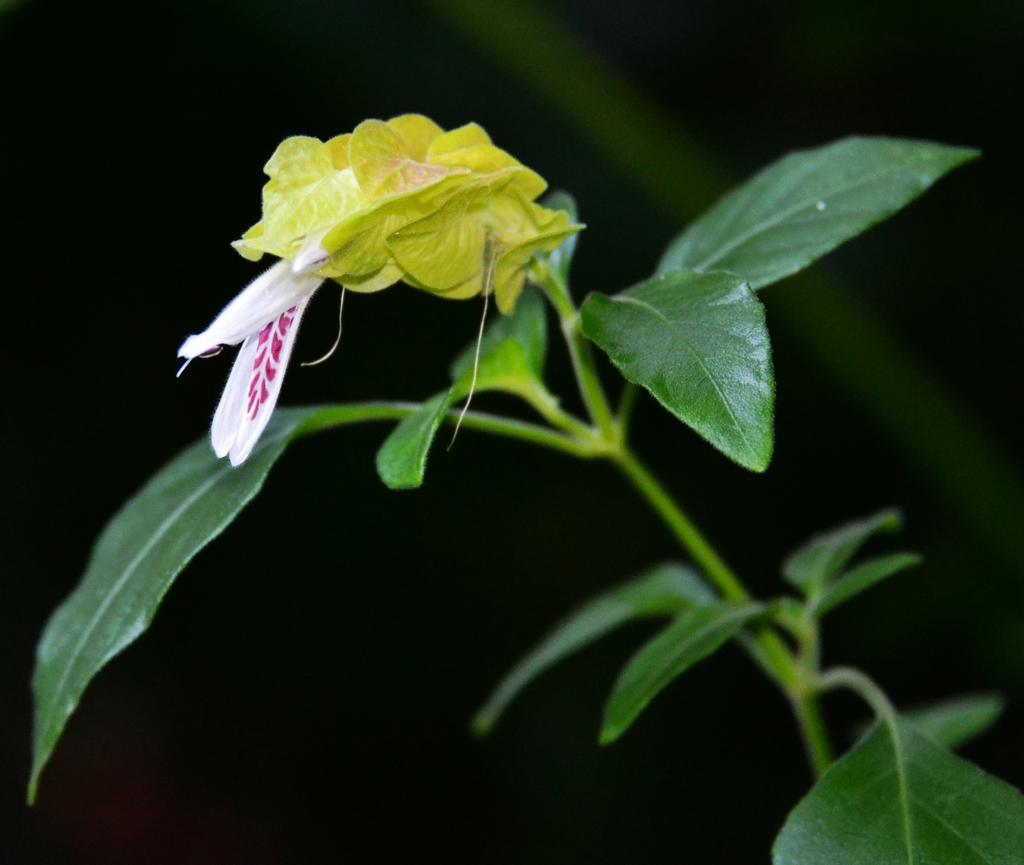What type of living organism is in the image? There is a plant in the image. What are the main features of the plant? The plant has leaves and flowers. What type of pear is hanging from the plant in the image? There is no pear present in the image; it is a plant with leaves and flowers. What type of apparel is the plant wearing in the image? Plants do not wear apparel, so this question cannot be answered. 